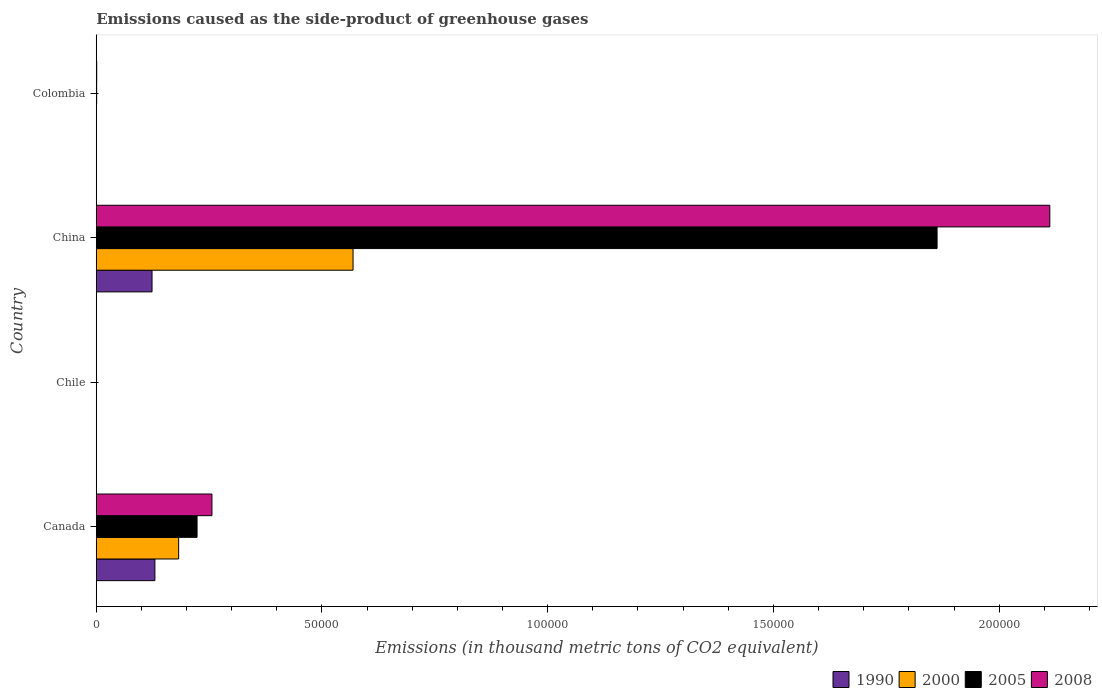Are the number of bars on each tick of the Y-axis equal?
Ensure brevity in your answer.  Yes. How many bars are there on the 4th tick from the top?
Provide a short and direct response. 4. What is the label of the 2nd group of bars from the top?
Keep it short and to the point. China. What is the emissions caused as the side-product of greenhouse gases in 2005 in Canada?
Your answer should be compact. 2.23e+04. Across all countries, what is the maximum emissions caused as the side-product of greenhouse gases in 2005?
Your response must be concise. 1.86e+05. In which country was the emissions caused as the side-product of greenhouse gases in 1990 maximum?
Your answer should be compact. Canada. In which country was the emissions caused as the side-product of greenhouse gases in 2005 minimum?
Provide a succinct answer. Chile. What is the total emissions caused as the side-product of greenhouse gases in 2005 in the graph?
Give a very brief answer. 2.09e+05. What is the difference between the emissions caused as the side-product of greenhouse gases in 2008 in Canada and that in Colombia?
Ensure brevity in your answer.  2.55e+04. What is the difference between the emissions caused as the side-product of greenhouse gases in 2005 in Colombia and the emissions caused as the side-product of greenhouse gases in 2000 in China?
Ensure brevity in your answer.  -5.68e+04. What is the average emissions caused as the side-product of greenhouse gases in 2005 per country?
Offer a terse response. 5.22e+04. In how many countries, is the emissions caused as the side-product of greenhouse gases in 2005 greater than 130000 thousand metric tons?
Your response must be concise. 1. What is the ratio of the emissions caused as the side-product of greenhouse gases in 2000 in Canada to that in China?
Your answer should be compact. 0.32. Is the emissions caused as the side-product of greenhouse gases in 2000 in Canada less than that in Colombia?
Ensure brevity in your answer.  No. What is the difference between the highest and the second highest emissions caused as the side-product of greenhouse gases in 2008?
Make the answer very short. 1.86e+05. What is the difference between the highest and the lowest emissions caused as the side-product of greenhouse gases in 1990?
Your response must be concise. 1.30e+04. In how many countries, is the emissions caused as the side-product of greenhouse gases in 2008 greater than the average emissions caused as the side-product of greenhouse gases in 2008 taken over all countries?
Your answer should be very brief. 1. Is the sum of the emissions caused as the side-product of greenhouse gases in 2008 in Chile and China greater than the maximum emissions caused as the side-product of greenhouse gases in 2005 across all countries?
Provide a short and direct response. Yes. Is it the case that in every country, the sum of the emissions caused as the side-product of greenhouse gases in 1990 and emissions caused as the side-product of greenhouse gases in 2008 is greater than the sum of emissions caused as the side-product of greenhouse gases in 2005 and emissions caused as the side-product of greenhouse gases in 2000?
Make the answer very short. No. Is it the case that in every country, the sum of the emissions caused as the side-product of greenhouse gases in 1990 and emissions caused as the side-product of greenhouse gases in 2000 is greater than the emissions caused as the side-product of greenhouse gases in 2005?
Your response must be concise. No. How many bars are there?
Offer a terse response. 16. Are all the bars in the graph horizontal?
Offer a terse response. Yes. What is the difference between two consecutive major ticks on the X-axis?
Provide a short and direct response. 5.00e+04. Where does the legend appear in the graph?
Make the answer very short. Bottom right. How many legend labels are there?
Give a very brief answer. 4. How are the legend labels stacked?
Your response must be concise. Horizontal. What is the title of the graph?
Make the answer very short. Emissions caused as the side-product of greenhouse gases. What is the label or title of the X-axis?
Provide a short and direct response. Emissions (in thousand metric tons of CO2 equivalent). What is the label or title of the Y-axis?
Keep it short and to the point. Country. What is the Emissions (in thousand metric tons of CO2 equivalent) in 1990 in Canada?
Your answer should be very brief. 1.30e+04. What is the Emissions (in thousand metric tons of CO2 equivalent) of 2000 in Canada?
Your answer should be compact. 1.82e+04. What is the Emissions (in thousand metric tons of CO2 equivalent) in 2005 in Canada?
Your answer should be compact. 2.23e+04. What is the Emissions (in thousand metric tons of CO2 equivalent) in 2008 in Canada?
Offer a terse response. 2.56e+04. What is the Emissions (in thousand metric tons of CO2 equivalent) of 2005 in Chile?
Offer a terse response. 9.2. What is the Emissions (in thousand metric tons of CO2 equivalent) in 1990 in China?
Provide a succinct answer. 1.24e+04. What is the Emissions (in thousand metric tons of CO2 equivalent) of 2000 in China?
Provide a short and direct response. 5.69e+04. What is the Emissions (in thousand metric tons of CO2 equivalent) of 2005 in China?
Ensure brevity in your answer.  1.86e+05. What is the Emissions (in thousand metric tons of CO2 equivalent) in 2008 in China?
Offer a very short reply. 2.11e+05. What is the Emissions (in thousand metric tons of CO2 equivalent) of 1990 in Colombia?
Give a very brief answer. 41.9. What is the Emissions (in thousand metric tons of CO2 equivalent) of 2000 in Colombia?
Make the answer very short. 28.4. What is the Emissions (in thousand metric tons of CO2 equivalent) in 2005 in Colombia?
Make the answer very short. 83.1. What is the Emissions (in thousand metric tons of CO2 equivalent) of 2008 in Colombia?
Your answer should be very brief. 96.9. Across all countries, what is the maximum Emissions (in thousand metric tons of CO2 equivalent) in 1990?
Provide a succinct answer. 1.30e+04. Across all countries, what is the maximum Emissions (in thousand metric tons of CO2 equivalent) in 2000?
Keep it short and to the point. 5.69e+04. Across all countries, what is the maximum Emissions (in thousand metric tons of CO2 equivalent) in 2005?
Your response must be concise. 1.86e+05. Across all countries, what is the maximum Emissions (in thousand metric tons of CO2 equivalent) of 2008?
Provide a short and direct response. 2.11e+05. What is the total Emissions (in thousand metric tons of CO2 equivalent) in 1990 in the graph?
Your answer should be compact. 2.54e+04. What is the total Emissions (in thousand metric tons of CO2 equivalent) of 2000 in the graph?
Offer a terse response. 7.52e+04. What is the total Emissions (in thousand metric tons of CO2 equivalent) of 2005 in the graph?
Provide a succinct answer. 2.09e+05. What is the total Emissions (in thousand metric tons of CO2 equivalent) in 2008 in the graph?
Your answer should be compact. 2.37e+05. What is the difference between the Emissions (in thousand metric tons of CO2 equivalent) of 1990 in Canada and that in Chile?
Offer a terse response. 1.30e+04. What is the difference between the Emissions (in thousand metric tons of CO2 equivalent) of 2000 in Canada and that in Chile?
Offer a terse response. 1.82e+04. What is the difference between the Emissions (in thousand metric tons of CO2 equivalent) in 2005 in Canada and that in Chile?
Make the answer very short. 2.23e+04. What is the difference between the Emissions (in thousand metric tons of CO2 equivalent) in 2008 in Canada and that in Chile?
Give a very brief answer. 2.56e+04. What is the difference between the Emissions (in thousand metric tons of CO2 equivalent) of 1990 in Canada and that in China?
Offer a very short reply. 637.4. What is the difference between the Emissions (in thousand metric tons of CO2 equivalent) in 2000 in Canada and that in China?
Provide a short and direct response. -3.86e+04. What is the difference between the Emissions (in thousand metric tons of CO2 equivalent) in 2005 in Canada and that in China?
Provide a short and direct response. -1.64e+05. What is the difference between the Emissions (in thousand metric tons of CO2 equivalent) of 2008 in Canada and that in China?
Your answer should be compact. -1.86e+05. What is the difference between the Emissions (in thousand metric tons of CO2 equivalent) in 1990 in Canada and that in Colombia?
Your answer should be very brief. 1.29e+04. What is the difference between the Emissions (in thousand metric tons of CO2 equivalent) in 2000 in Canada and that in Colombia?
Your answer should be very brief. 1.82e+04. What is the difference between the Emissions (in thousand metric tons of CO2 equivalent) of 2005 in Canada and that in Colombia?
Provide a short and direct response. 2.22e+04. What is the difference between the Emissions (in thousand metric tons of CO2 equivalent) of 2008 in Canada and that in Colombia?
Your answer should be compact. 2.55e+04. What is the difference between the Emissions (in thousand metric tons of CO2 equivalent) of 1990 in Chile and that in China?
Give a very brief answer. -1.23e+04. What is the difference between the Emissions (in thousand metric tons of CO2 equivalent) in 2000 in Chile and that in China?
Give a very brief answer. -5.69e+04. What is the difference between the Emissions (in thousand metric tons of CO2 equivalent) in 2005 in Chile and that in China?
Make the answer very short. -1.86e+05. What is the difference between the Emissions (in thousand metric tons of CO2 equivalent) of 2008 in Chile and that in China?
Your response must be concise. -2.11e+05. What is the difference between the Emissions (in thousand metric tons of CO2 equivalent) of 1990 in Chile and that in Colombia?
Provide a succinct answer. -25.2. What is the difference between the Emissions (in thousand metric tons of CO2 equivalent) of 2000 in Chile and that in Colombia?
Offer a terse response. -21.5. What is the difference between the Emissions (in thousand metric tons of CO2 equivalent) in 2005 in Chile and that in Colombia?
Provide a succinct answer. -73.9. What is the difference between the Emissions (in thousand metric tons of CO2 equivalent) of 2008 in Chile and that in Colombia?
Ensure brevity in your answer.  -88.8. What is the difference between the Emissions (in thousand metric tons of CO2 equivalent) of 1990 in China and that in Colombia?
Provide a succinct answer. 1.23e+04. What is the difference between the Emissions (in thousand metric tons of CO2 equivalent) of 2000 in China and that in Colombia?
Make the answer very short. 5.69e+04. What is the difference between the Emissions (in thousand metric tons of CO2 equivalent) in 2005 in China and that in Colombia?
Your answer should be compact. 1.86e+05. What is the difference between the Emissions (in thousand metric tons of CO2 equivalent) of 2008 in China and that in Colombia?
Make the answer very short. 2.11e+05. What is the difference between the Emissions (in thousand metric tons of CO2 equivalent) in 1990 in Canada and the Emissions (in thousand metric tons of CO2 equivalent) in 2000 in Chile?
Offer a terse response. 1.30e+04. What is the difference between the Emissions (in thousand metric tons of CO2 equivalent) in 1990 in Canada and the Emissions (in thousand metric tons of CO2 equivalent) in 2005 in Chile?
Offer a very short reply. 1.30e+04. What is the difference between the Emissions (in thousand metric tons of CO2 equivalent) in 1990 in Canada and the Emissions (in thousand metric tons of CO2 equivalent) in 2008 in Chile?
Your answer should be very brief. 1.30e+04. What is the difference between the Emissions (in thousand metric tons of CO2 equivalent) in 2000 in Canada and the Emissions (in thousand metric tons of CO2 equivalent) in 2005 in Chile?
Offer a terse response. 1.82e+04. What is the difference between the Emissions (in thousand metric tons of CO2 equivalent) in 2000 in Canada and the Emissions (in thousand metric tons of CO2 equivalent) in 2008 in Chile?
Your response must be concise. 1.82e+04. What is the difference between the Emissions (in thousand metric tons of CO2 equivalent) in 2005 in Canada and the Emissions (in thousand metric tons of CO2 equivalent) in 2008 in Chile?
Make the answer very short. 2.23e+04. What is the difference between the Emissions (in thousand metric tons of CO2 equivalent) of 1990 in Canada and the Emissions (in thousand metric tons of CO2 equivalent) of 2000 in China?
Provide a succinct answer. -4.39e+04. What is the difference between the Emissions (in thousand metric tons of CO2 equivalent) of 1990 in Canada and the Emissions (in thousand metric tons of CO2 equivalent) of 2005 in China?
Your answer should be very brief. -1.73e+05. What is the difference between the Emissions (in thousand metric tons of CO2 equivalent) of 1990 in Canada and the Emissions (in thousand metric tons of CO2 equivalent) of 2008 in China?
Offer a terse response. -1.98e+05. What is the difference between the Emissions (in thousand metric tons of CO2 equivalent) of 2000 in Canada and the Emissions (in thousand metric tons of CO2 equivalent) of 2005 in China?
Provide a short and direct response. -1.68e+05. What is the difference between the Emissions (in thousand metric tons of CO2 equivalent) in 2000 in Canada and the Emissions (in thousand metric tons of CO2 equivalent) in 2008 in China?
Provide a short and direct response. -1.93e+05. What is the difference between the Emissions (in thousand metric tons of CO2 equivalent) in 2005 in Canada and the Emissions (in thousand metric tons of CO2 equivalent) in 2008 in China?
Offer a terse response. -1.89e+05. What is the difference between the Emissions (in thousand metric tons of CO2 equivalent) of 1990 in Canada and the Emissions (in thousand metric tons of CO2 equivalent) of 2000 in Colombia?
Offer a terse response. 1.30e+04. What is the difference between the Emissions (in thousand metric tons of CO2 equivalent) of 1990 in Canada and the Emissions (in thousand metric tons of CO2 equivalent) of 2005 in Colombia?
Give a very brief answer. 1.29e+04. What is the difference between the Emissions (in thousand metric tons of CO2 equivalent) of 1990 in Canada and the Emissions (in thousand metric tons of CO2 equivalent) of 2008 in Colombia?
Your answer should be compact. 1.29e+04. What is the difference between the Emissions (in thousand metric tons of CO2 equivalent) of 2000 in Canada and the Emissions (in thousand metric tons of CO2 equivalent) of 2005 in Colombia?
Your response must be concise. 1.82e+04. What is the difference between the Emissions (in thousand metric tons of CO2 equivalent) in 2000 in Canada and the Emissions (in thousand metric tons of CO2 equivalent) in 2008 in Colombia?
Your answer should be very brief. 1.82e+04. What is the difference between the Emissions (in thousand metric tons of CO2 equivalent) in 2005 in Canada and the Emissions (in thousand metric tons of CO2 equivalent) in 2008 in Colombia?
Give a very brief answer. 2.22e+04. What is the difference between the Emissions (in thousand metric tons of CO2 equivalent) in 1990 in Chile and the Emissions (in thousand metric tons of CO2 equivalent) in 2000 in China?
Offer a very short reply. -5.69e+04. What is the difference between the Emissions (in thousand metric tons of CO2 equivalent) in 1990 in Chile and the Emissions (in thousand metric tons of CO2 equivalent) in 2005 in China?
Offer a terse response. -1.86e+05. What is the difference between the Emissions (in thousand metric tons of CO2 equivalent) of 1990 in Chile and the Emissions (in thousand metric tons of CO2 equivalent) of 2008 in China?
Provide a short and direct response. -2.11e+05. What is the difference between the Emissions (in thousand metric tons of CO2 equivalent) in 2000 in Chile and the Emissions (in thousand metric tons of CO2 equivalent) in 2005 in China?
Offer a very short reply. -1.86e+05. What is the difference between the Emissions (in thousand metric tons of CO2 equivalent) of 2000 in Chile and the Emissions (in thousand metric tons of CO2 equivalent) of 2008 in China?
Your answer should be compact. -2.11e+05. What is the difference between the Emissions (in thousand metric tons of CO2 equivalent) of 2005 in Chile and the Emissions (in thousand metric tons of CO2 equivalent) of 2008 in China?
Offer a very short reply. -2.11e+05. What is the difference between the Emissions (in thousand metric tons of CO2 equivalent) of 1990 in Chile and the Emissions (in thousand metric tons of CO2 equivalent) of 2005 in Colombia?
Make the answer very short. -66.4. What is the difference between the Emissions (in thousand metric tons of CO2 equivalent) of 1990 in Chile and the Emissions (in thousand metric tons of CO2 equivalent) of 2008 in Colombia?
Your answer should be compact. -80.2. What is the difference between the Emissions (in thousand metric tons of CO2 equivalent) of 2000 in Chile and the Emissions (in thousand metric tons of CO2 equivalent) of 2005 in Colombia?
Offer a very short reply. -76.2. What is the difference between the Emissions (in thousand metric tons of CO2 equivalent) in 2000 in Chile and the Emissions (in thousand metric tons of CO2 equivalent) in 2008 in Colombia?
Offer a terse response. -90. What is the difference between the Emissions (in thousand metric tons of CO2 equivalent) of 2005 in Chile and the Emissions (in thousand metric tons of CO2 equivalent) of 2008 in Colombia?
Provide a succinct answer. -87.7. What is the difference between the Emissions (in thousand metric tons of CO2 equivalent) of 1990 in China and the Emissions (in thousand metric tons of CO2 equivalent) of 2000 in Colombia?
Give a very brief answer. 1.23e+04. What is the difference between the Emissions (in thousand metric tons of CO2 equivalent) in 1990 in China and the Emissions (in thousand metric tons of CO2 equivalent) in 2005 in Colombia?
Keep it short and to the point. 1.23e+04. What is the difference between the Emissions (in thousand metric tons of CO2 equivalent) of 1990 in China and the Emissions (in thousand metric tons of CO2 equivalent) of 2008 in Colombia?
Your response must be concise. 1.23e+04. What is the difference between the Emissions (in thousand metric tons of CO2 equivalent) of 2000 in China and the Emissions (in thousand metric tons of CO2 equivalent) of 2005 in Colombia?
Your answer should be compact. 5.68e+04. What is the difference between the Emissions (in thousand metric tons of CO2 equivalent) of 2000 in China and the Emissions (in thousand metric tons of CO2 equivalent) of 2008 in Colombia?
Keep it short and to the point. 5.68e+04. What is the difference between the Emissions (in thousand metric tons of CO2 equivalent) of 2005 in China and the Emissions (in thousand metric tons of CO2 equivalent) of 2008 in Colombia?
Make the answer very short. 1.86e+05. What is the average Emissions (in thousand metric tons of CO2 equivalent) in 1990 per country?
Offer a very short reply. 6350.6. What is the average Emissions (in thousand metric tons of CO2 equivalent) of 2000 per country?
Your answer should be compact. 1.88e+04. What is the average Emissions (in thousand metric tons of CO2 equivalent) of 2005 per country?
Your answer should be compact. 5.22e+04. What is the average Emissions (in thousand metric tons of CO2 equivalent) of 2008 per country?
Offer a terse response. 5.92e+04. What is the difference between the Emissions (in thousand metric tons of CO2 equivalent) in 1990 and Emissions (in thousand metric tons of CO2 equivalent) in 2000 in Canada?
Your response must be concise. -5257.2. What is the difference between the Emissions (in thousand metric tons of CO2 equivalent) in 1990 and Emissions (in thousand metric tons of CO2 equivalent) in 2005 in Canada?
Make the answer very short. -9339.6. What is the difference between the Emissions (in thousand metric tons of CO2 equivalent) in 1990 and Emissions (in thousand metric tons of CO2 equivalent) in 2008 in Canada?
Offer a very short reply. -1.26e+04. What is the difference between the Emissions (in thousand metric tons of CO2 equivalent) of 2000 and Emissions (in thousand metric tons of CO2 equivalent) of 2005 in Canada?
Your answer should be compact. -4082.4. What is the difference between the Emissions (in thousand metric tons of CO2 equivalent) of 2000 and Emissions (in thousand metric tons of CO2 equivalent) of 2008 in Canada?
Your answer should be very brief. -7379.5. What is the difference between the Emissions (in thousand metric tons of CO2 equivalent) in 2005 and Emissions (in thousand metric tons of CO2 equivalent) in 2008 in Canada?
Give a very brief answer. -3297.1. What is the difference between the Emissions (in thousand metric tons of CO2 equivalent) in 1990 and Emissions (in thousand metric tons of CO2 equivalent) in 2000 in Chile?
Your response must be concise. 9.8. What is the difference between the Emissions (in thousand metric tons of CO2 equivalent) in 1990 and Emissions (in thousand metric tons of CO2 equivalent) in 2008 in Chile?
Your response must be concise. 8.6. What is the difference between the Emissions (in thousand metric tons of CO2 equivalent) in 2000 and Emissions (in thousand metric tons of CO2 equivalent) in 2008 in Chile?
Give a very brief answer. -1.2. What is the difference between the Emissions (in thousand metric tons of CO2 equivalent) of 2005 and Emissions (in thousand metric tons of CO2 equivalent) of 2008 in Chile?
Ensure brevity in your answer.  1.1. What is the difference between the Emissions (in thousand metric tons of CO2 equivalent) in 1990 and Emissions (in thousand metric tons of CO2 equivalent) in 2000 in China?
Keep it short and to the point. -4.45e+04. What is the difference between the Emissions (in thousand metric tons of CO2 equivalent) in 1990 and Emissions (in thousand metric tons of CO2 equivalent) in 2005 in China?
Ensure brevity in your answer.  -1.74e+05. What is the difference between the Emissions (in thousand metric tons of CO2 equivalent) of 1990 and Emissions (in thousand metric tons of CO2 equivalent) of 2008 in China?
Provide a succinct answer. -1.99e+05. What is the difference between the Emissions (in thousand metric tons of CO2 equivalent) in 2000 and Emissions (in thousand metric tons of CO2 equivalent) in 2005 in China?
Ensure brevity in your answer.  -1.29e+05. What is the difference between the Emissions (in thousand metric tons of CO2 equivalent) in 2000 and Emissions (in thousand metric tons of CO2 equivalent) in 2008 in China?
Offer a very short reply. -1.54e+05. What is the difference between the Emissions (in thousand metric tons of CO2 equivalent) of 2005 and Emissions (in thousand metric tons of CO2 equivalent) of 2008 in China?
Keep it short and to the point. -2.50e+04. What is the difference between the Emissions (in thousand metric tons of CO2 equivalent) in 1990 and Emissions (in thousand metric tons of CO2 equivalent) in 2005 in Colombia?
Keep it short and to the point. -41.2. What is the difference between the Emissions (in thousand metric tons of CO2 equivalent) of 1990 and Emissions (in thousand metric tons of CO2 equivalent) of 2008 in Colombia?
Your answer should be compact. -55. What is the difference between the Emissions (in thousand metric tons of CO2 equivalent) of 2000 and Emissions (in thousand metric tons of CO2 equivalent) of 2005 in Colombia?
Make the answer very short. -54.7. What is the difference between the Emissions (in thousand metric tons of CO2 equivalent) in 2000 and Emissions (in thousand metric tons of CO2 equivalent) in 2008 in Colombia?
Ensure brevity in your answer.  -68.5. What is the difference between the Emissions (in thousand metric tons of CO2 equivalent) in 2005 and Emissions (in thousand metric tons of CO2 equivalent) in 2008 in Colombia?
Provide a short and direct response. -13.8. What is the ratio of the Emissions (in thousand metric tons of CO2 equivalent) in 1990 in Canada to that in Chile?
Your answer should be very brief. 777.88. What is the ratio of the Emissions (in thousand metric tons of CO2 equivalent) of 2000 in Canada to that in Chile?
Provide a short and direct response. 2644.61. What is the ratio of the Emissions (in thousand metric tons of CO2 equivalent) in 2005 in Canada to that in Chile?
Provide a succinct answer. 2427.2. What is the ratio of the Emissions (in thousand metric tons of CO2 equivalent) of 2008 in Canada to that in Chile?
Provide a short and direct response. 3163.86. What is the ratio of the Emissions (in thousand metric tons of CO2 equivalent) in 1990 in Canada to that in China?
Ensure brevity in your answer.  1.05. What is the ratio of the Emissions (in thousand metric tons of CO2 equivalent) of 2000 in Canada to that in China?
Your answer should be very brief. 0.32. What is the ratio of the Emissions (in thousand metric tons of CO2 equivalent) of 2005 in Canada to that in China?
Your answer should be compact. 0.12. What is the ratio of the Emissions (in thousand metric tons of CO2 equivalent) of 2008 in Canada to that in China?
Your response must be concise. 0.12. What is the ratio of the Emissions (in thousand metric tons of CO2 equivalent) in 1990 in Canada to that in Colombia?
Offer a terse response. 310.04. What is the ratio of the Emissions (in thousand metric tons of CO2 equivalent) in 2000 in Canada to that in Colombia?
Keep it short and to the point. 642.53. What is the ratio of the Emissions (in thousand metric tons of CO2 equivalent) of 2005 in Canada to that in Colombia?
Your answer should be compact. 268.71. What is the ratio of the Emissions (in thousand metric tons of CO2 equivalent) in 2008 in Canada to that in Colombia?
Offer a terse response. 264.47. What is the ratio of the Emissions (in thousand metric tons of CO2 equivalent) in 1990 in Chile to that in China?
Offer a very short reply. 0. What is the ratio of the Emissions (in thousand metric tons of CO2 equivalent) in 2005 in Chile to that in China?
Your answer should be compact. 0. What is the ratio of the Emissions (in thousand metric tons of CO2 equivalent) of 2008 in Chile to that in China?
Make the answer very short. 0. What is the ratio of the Emissions (in thousand metric tons of CO2 equivalent) of 1990 in Chile to that in Colombia?
Make the answer very short. 0.4. What is the ratio of the Emissions (in thousand metric tons of CO2 equivalent) in 2000 in Chile to that in Colombia?
Keep it short and to the point. 0.24. What is the ratio of the Emissions (in thousand metric tons of CO2 equivalent) in 2005 in Chile to that in Colombia?
Provide a succinct answer. 0.11. What is the ratio of the Emissions (in thousand metric tons of CO2 equivalent) in 2008 in Chile to that in Colombia?
Provide a succinct answer. 0.08. What is the ratio of the Emissions (in thousand metric tons of CO2 equivalent) in 1990 in China to that in Colombia?
Offer a very short reply. 294.83. What is the ratio of the Emissions (in thousand metric tons of CO2 equivalent) in 2000 in China to that in Colombia?
Give a very brief answer. 2002.89. What is the ratio of the Emissions (in thousand metric tons of CO2 equivalent) of 2005 in China to that in Colombia?
Your answer should be very brief. 2241.32. What is the ratio of the Emissions (in thousand metric tons of CO2 equivalent) of 2008 in China to that in Colombia?
Keep it short and to the point. 2179.83. What is the difference between the highest and the second highest Emissions (in thousand metric tons of CO2 equivalent) of 1990?
Your answer should be compact. 637.4. What is the difference between the highest and the second highest Emissions (in thousand metric tons of CO2 equivalent) in 2000?
Ensure brevity in your answer.  3.86e+04. What is the difference between the highest and the second highest Emissions (in thousand metric tons of CO2 equivalent) of 2005?
Ensure brevity in your answer.  1.64e+05. What is the difference between the highest and the second highest Emissions (in thousand metric tons of CO2 equivalent) of 2008?
Provide a succinct answer. 1.86e+05. What is the difference between the highest and the lowest Emissions (in thousand metric tons of CO2 equivalent) of 1990?
Your response must be concise. 1.30e+04. What is the difference between the highest and the lowest Emissions (in thousand metric tons of CO2 equivalent) of 2000?
Offer a terse response. 5.69e+04. What is the difference between the highest and the lowest Emissions (in thousand metric tons of CO2 equivalent) in 2005?
Your response must be concise. 1.86e+05. What is the difference between the highest and the lowest Emissions (in thousand metric tons of CO2 equivalent) in 2008?
Your answer should be very brief. 2.11e+05. 